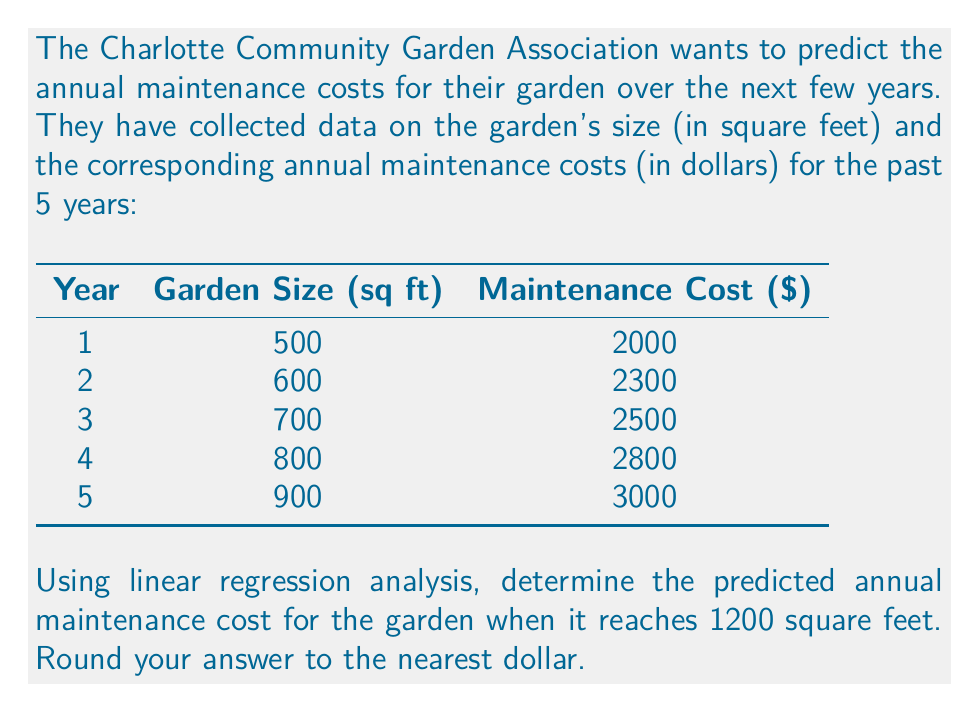Give your solution to this math problem. To solve this problem, we'll use linear regression analysis to find the line of best fit for the given data points. Then, we'll use the resulting equation to predict the maintenance cost for a 1200 square foot garden.

Step 1: Set up the linear regression equation
Let $x$ represent the garden size and $y$ represent the maintenance cost. The linear regression equation is of the form:

$$ y = mx + b $$

where $m$ is the slope and $b$ is the y-intercept.

Step 2: Calculate the slope (m)
Using the formula:

$$ m = \frac{n\sum{xy} - \sum{x}\sum{y}}{n\sum{x^2} - (\sum{x})^2} $$

Where $n$ is the number of data points (5 in this case).

$\sum{x} = 500 + 600 + 700 + 800 + 900 = 3500$
$\sum{y} = 2000 + 2300 + 2500 + 2800 + 3000 = 12600$
$\sum{xy} = (500 \times 2000) + (600 \times 2300) + (700 \times 2500) + (800 \times 2800) + (900 \times 3000) = 9,020,000$
$\sum{x^2} = 500^2 + 600^2 + 700^2 + 800^2 + 900^2 = 2,525,000$

Plugging these values into the slope formula:

$$ m = \frac{5(9,020,000) - (3500)(12600)}{5(2,525,000) - (3500)^2} = \frac{45,100,000 - 44,100,000}{12,625,000 - 12,250,000} = \frac{1,000,000}{375,000} = \frac{8}{3} \approx 2.67 $$

Step 3: Calculate the y-intercept (b)
Using the formula:

$$ b = \frac{\sum{y} - m\sum{x}}{n} $$

$$ b = \frac{12600 - \frac{8}{3}(3500)}{5} = \frac{12600 - 9333.33}{5} = 653.33 $$

Step 4: Write the regression equation
$$ y = 2.67x + 653.33 $$

Step 5: Predict the maintenance cost for a 1200 square foot garden
Substitute $x = 1200$ into the regression equation:

$$ y = 2.67(1200) + 653.33 = 3204 + 653.33 = 3857.33 $$

Rounding to the nearest dollar, we get $3857.
Answer: $3857 